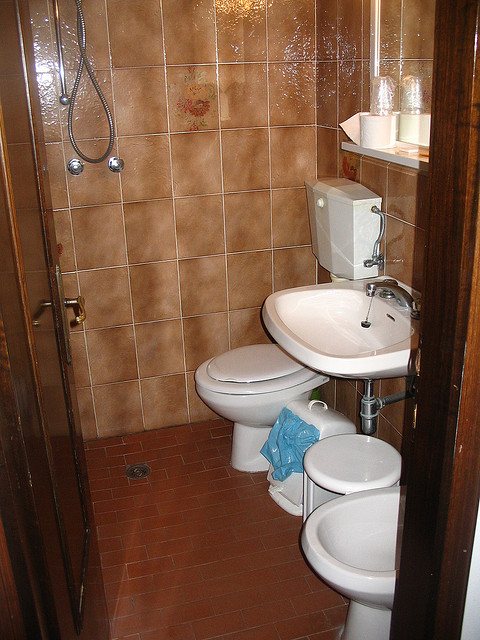What design style does this bathroom represent? The bathroom features a practical and traditional design, with ceramic fixtures and tiled walls. The use of earth tones and a simple, unadorned aesthetic is consistent with a classic, functional approach to bathroom design. 